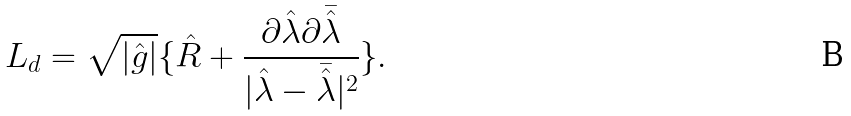<formula> <loc_0><loc_0><loc_500><loc_500>L _ { d } = \sqrt { | \hat { g } | } \{ \hat { R } + \frac { \partial \hat { \lambda } \partial \bar { \hat { \lambda } } } { | \hat { \lambda } - \bar { \hat { \lambda } } | ^ { 2 } } \} .</formula> 